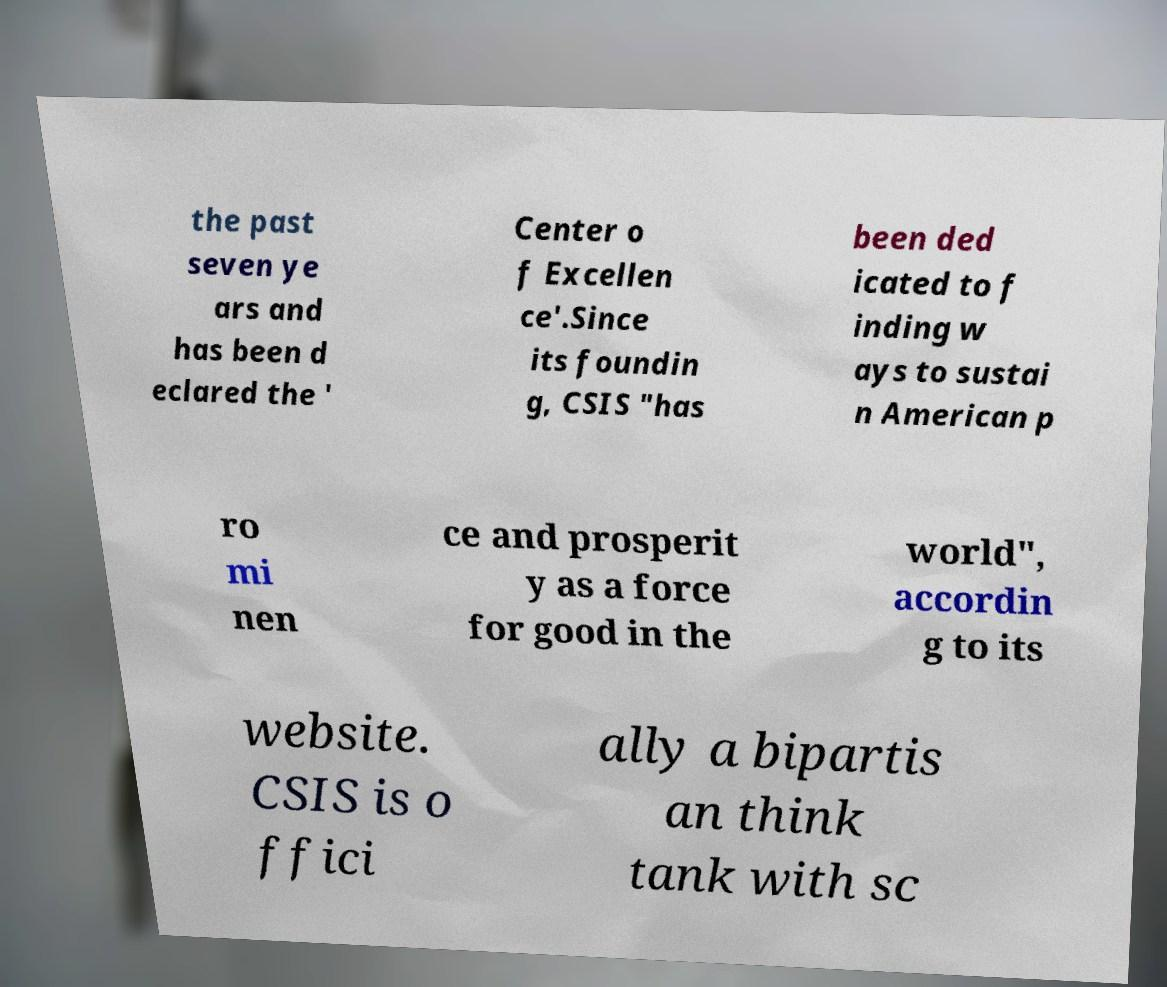Can you accurately transcribe the text from the provided image for me? the past seven ye ars and has been d eclared the ' Center o f Excellen ce'.Since its foundin g, CSIS "has been ded icated to f inding w ays to sustai n American p ro mi nen ce and prosperit y as a force for good in the world", accordin g to its website. CSIS is o ffici ally a bipartis an think tank with sc 